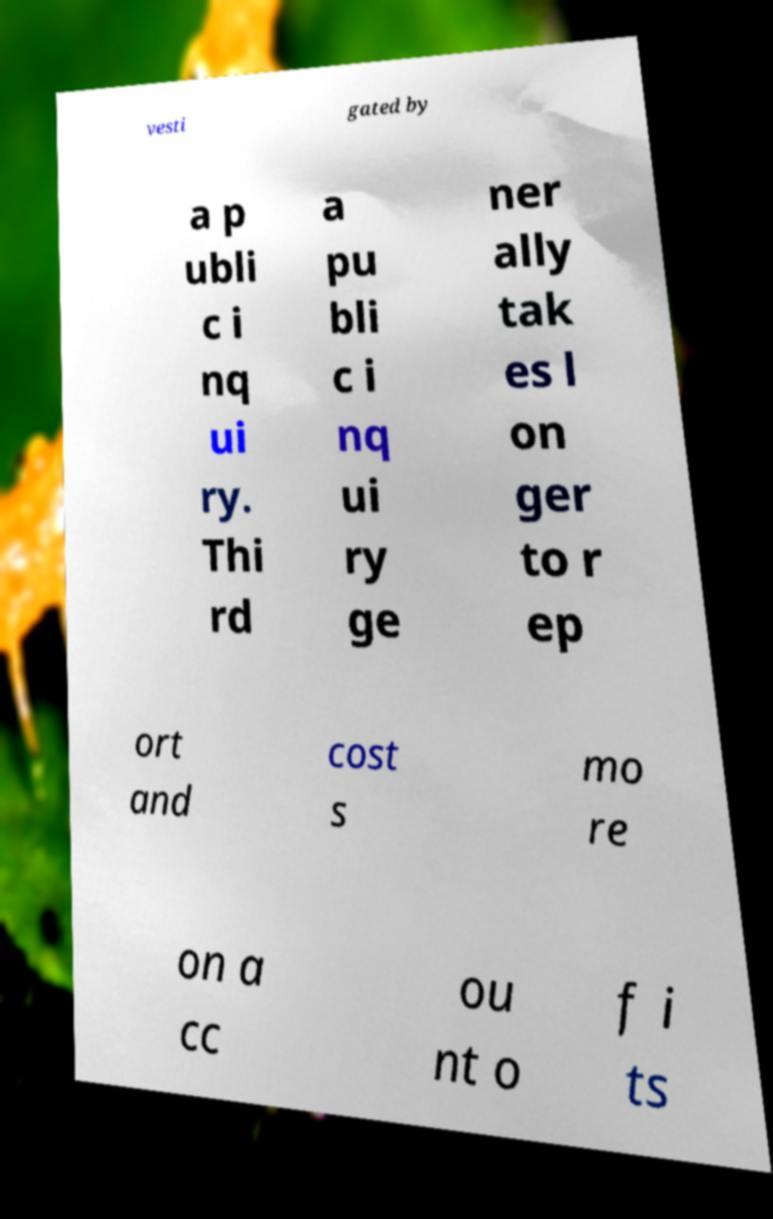Can you accurately transcribe the text from the provided image for me? vesti gated by a p ubli c i nq ui ry. Thi rd a pu bli c i nq ui ry ge ner ally tak es l on ger to r ep ort and cost s mo re on a cc ou nt o f i ts 